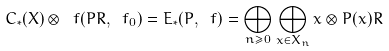<formula> <loc_0><loc_0><loc_500><loc_500>C _ { \ast } ( X ) \otimes _ { \ } f ( P R , \ f _ { 0 } ) = E _ { \ast } ( P , \ f ) = \bigoplus _ { n \geq 0 } \bigoplus _ { x \in X _ { n } } x \otimes P ( x ) R</formula> 